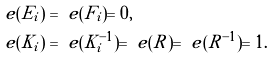<formula> <loc_0><loc_0><loc_500><loc_500>\ e ( E _ { i } ) & = \ e ( F _ { i } ) = 0 , \\ \ e ( K _ { i } ) & = \ e ( K _ { i } ^ { - 1 } ) = \ e ( R ) = \ e ( R ^ { - 1 } ) = 1 .</formula> 